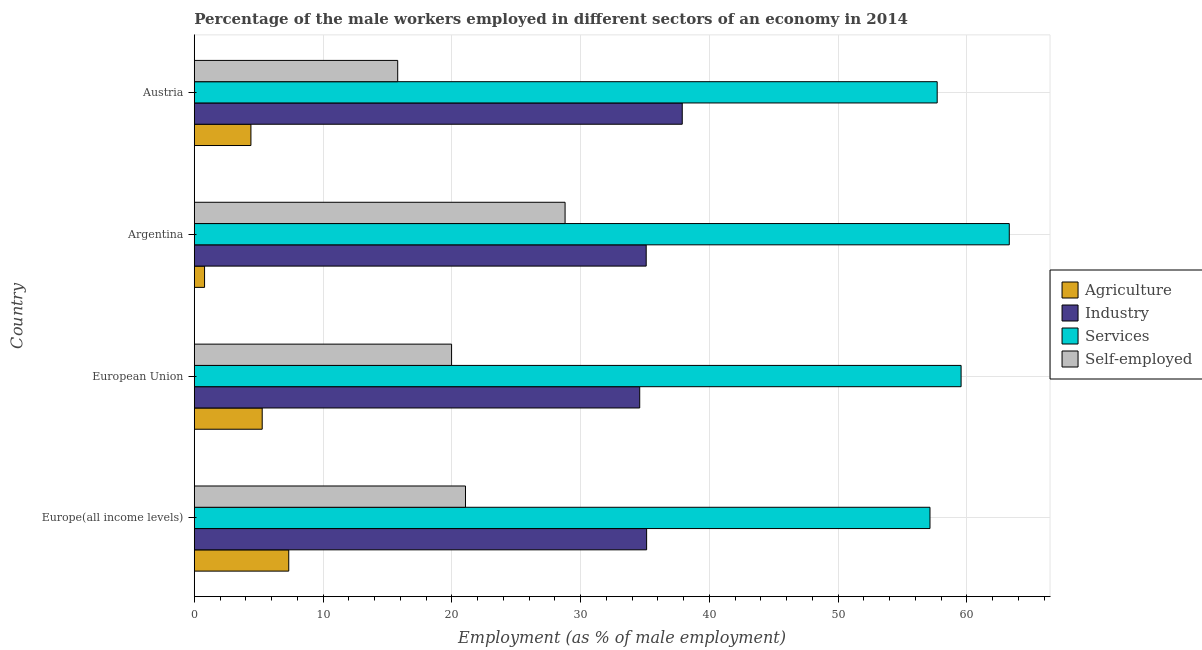How many groups of bars are there?
Give a very brief answer. 4. Are the number of bars on each tick of the Y-axis equal?
Your answer should be very brief. Yes. How many bars are there on the 1st tick from the bottom?
Give a very brief answer. 4. What is the label of the 3rd group of bars from the top?
Offer a terse response. European Union. What is the percentage of self employed male workers in Argentina?
Ensure brevity in your answer.  28.8. Across all countries, what is the maximum percentage of male workers in industry?
Your answer should be compact. 37.9. Across all countries, what is the minimum percentage of male workers in agriculture?
Your response must be concise. 0.8. In which country was the percentage of male workers in services maximum?
Provide a short and direct response. Argentina. In which country was the percentage of male workers in services minimum?
Offer a very short reply. Europe(all income levels). What is the total percentage of self employed male workers in the graph?
Provide a succinct answer. 85.65. What is the difference between the percentage of male workers in agriculture in Austria and that in European Union?
Your answer should be very brief. -0.88. What is the difference between the percentage of male workers in services in Argentina and the percentage of self employed male workers in Europe(all income levels)?
Your response must be concise. 42.24. What is the average percentage of self employed male workers per country?
Keep it short and to the point. 21.41. What is the difference between the percentage of male workers in services and percentage of male workers in industry in Argentina?
Keep it short and to the point. 28.2. In how many countries, is the percentage of male workers in services greater than 50 %?
Your answer should be very brief. 4. What is the ratio of the percentage of male workers in services in Austria to that in European Union?
Keep it short and to the point. 0.97. Is the difference between the percentage of male workers in agriculture in Austria and Europe(all income levels) greater than the difference between the percentage of self employed male workers in Austria and Europe(all income levels)?
Offer a terse response. Yes. What is the difference between the highest and the second highest percentage of male workers in services?
Offer a very short reply. 3.74. Is the sum of the percentage of male workers in agriculture in Argentina and Europe(all income levels) greater than the maximum percentage of male workers in services across all countries?
Offer a terse response. No. What does the 1st bar from the top in Austria represents?
Your answer should be very brief. Self-employed. What does the 1st bar from the bottom in Europe(all income levels) represents?
Keep it short and to the point. Agriculture. Is it the case that in every country, the sum of the percentage of male workers in agriculture and percentage of male workers in industry is greater than the percentage of male workers in services?
Keep it short and to the point. No. How many bars are there?
Provide a succinct answer. 16. Are all the bars in the graph horizontal?
Give a very brief answer. Yes. What is the difference between two consecutive major ticks on the X-axis?
Give a very brief answer. 10. Are the values on the major ticks of X-axis written in scientific E-notation?
Give a very brief answer. No. Does the graph contain any zero values?
Offer a terse response. No. How are the legend labels stacked?
Make the answer very short. Vertical. What is the title of the graph?
Keep it short and to the point. Percentage of the male workers employed in different sectors of an economy in 2014. What is the label or title of the X-axis?
Offer a very short reply. Employment (as % of male employment). What is the label or title of the Y-axis?
Your response must be concise. Country. What is the Employment (as % of male employment) in Agriculture in Europe(all income levels)?
Your answer should be very brief. 7.34. What is the Employment (as % of male employment) of Industry in Europe(all income levels)?
Offer a terse response. 35.13. What is the Employment (as % of male employment) of Services in Europe(all income levels)?
Provide a short and direct response. 57.14. What is the Employment (as % of male employment) of Self-employed in Europe(all income levels)?
Offer a very short reply. 21.06. What is the Employment (as % of male employment) of Agriculture in European Union?
Ensure brevity in your answer.  5.28. What is the Employment (as % of male employment) of Industry in European Union?
Ensure brevity in your answer.  34.6. What is the Employment (as % of male employment) in Services in European Union?
Keep it short and to the point. 59.56. What is the Employment (as % of male employment) in Self-employed in European Union?
Your answer should be very brief. 19.98. What is the Employment (as % of male employment) in Agriculture in Argentina?
Keep it short and to the point. 0.8. What is the Employment (as % of male employment) in Industry in Argentina?
Offer a very short reply. 35.1. What is the Employment (as % of male employment) in Services in Argentina?
Offer a very short reply. 63.3. What is the Employment (as % of male employment) in Self-employed in Argentina?
Your answer should be compact. 28.8. What is the Employment (as % of male employment) of Agriculture in Austria?
Keep it short and to the point. 4.4. What is the Employment (as % of male employment) in Industry in Austria?
Provide a succinct answer. 37.9. What is the Employment (as % of male employment) of Services in Austria?
Your answer should be very brief. 57.7. What is the Employment (as % of male employment) in Self-employed in Austria?
Your response must be concise. 15.8. Across all countries, what is the maximum Employment (as % of male employment) in Agriculture?
Your answer should be very brief. 7.34. Across all countries, what is the maximum Employment (as % of male employment) of Industry?
Give a very brief answer. 37.9. Across all countries, what is the maximum Employment (as % of male employment) of Services?
Your answer should be very brief. 63.3. Across all countries, what is the maximum Employment (as % of male employment) of Self-employed?
Offer a very short reply. 28.8. Across all countries, what is the minimum Employment (as % of male employment) of Agriculture?
Offer a terse response. 0.8. Across all countries, what is the minimum Employment (as % of male employment) in Industry?
Make the answer very short. 34.6. Across all countries, what is the minimum Employment (as % of male employment) in Services?
Ensure brevity in your answer.  57.14. Across all countries, what is the minimum Employment (as % of male employment) of Self-employed?
Your response must be concise. 15.8. What is the total Employment (as % of male employment) of Agriculture in the graph?
Ensure brevity in your answer.  17.82. What is the total Employment (as % of male employment) in Industry in the graph?
Make the answer very short. 142.73. What is the total Employment (as % of male employment) in Services in the graph?
Your answer should be very brief. 237.7. What is the total Employment (as % of male employment) of Self-employed in the graph?
Your answer should be compact. 85.65. What is the difference between the Employment (as % of male employment) of Agriculture in Europe(all income levels) and that in European Union?
Provide a succinct answer. 2.06. What is the difference between the Employment (as % of male employment) of Industry in Europe(all income levels) and that in European Union?
Provide a short and direct response. 0.54. What is the difference between the Employment (as % of male employment) in Services in Europe(all income levels) and that in European Union?
Ensure brevity in your answer.  -2.42. What is the difference between the Employment (as % of male employment) of Self-employed in Europe(all income levels) and that in European Union?
Give a very brief answer. 1.08. What is the difference between the Employment (as % of male employment) of Agriculture in Europe(all income levels) and that in Argentina?
Offer a very short reply. 6.54. What is the difference between the Employment (as % of male employment) of Industry in Europe(all income levels) and that in Argentina?
Give a very brief answer. 0.03. What is the difference between the Employment (as % of male employment) of Services in Europe(all income levels) and that in Argentina?
Your answer should be very brief. -6.16. What is the difference between the Employment (as % of male employment) of Self-employed in Europe(all income levels) and that in Argentina?
Ensure brevity in your answer.  -7.74. What is the difference between the Employment (as % of male employment) of Agriculture in Europe(all income levels) and that in Austria?
Keep it short and to the point. 2.94. What is the difference between the Employment (as % of male employment) in Industry in Europe(all income levels) and that in Austria?
Offer a terse response. -2.77. What is the difference between the Employment (as % of male employment) in Services in Europe(all income levels) and that in Austria?
Provide a short and direct response. -0.56. What is the difference between the Employment (as % of male employment) in Self-employed in Europe(all income levels) and that in Austria?
Ensure brevity in your answer.  5.26. What is the difference between the Employment (as % of male employment) in Agriculture in European Union and that in Argentina?
Ensure brevity in your answer.  4.48. What is the difference between the Employment (as % of male employment) of Industry in European Union and that in Argentina?
Make the answer very short. -0.5. What is the difference between the Employment (as % of male employment) of Services in European Union and that in Argentina?
Make the answer very short. -3.74. What is the difference between the Employment (as % of male employment) in Self-employed in European Union and that in Argentina?
Provide a succinct answer. -8.82. What is the difference between the Employment (as % of male employment) of Agriculture in European Union and that in Austria?
Your answer should be compact. 0.88. What is the difference between the Employment (as % of male employment) in Industry in European Union and that in Austria?
Offer a terse response. -3.3. What is the difference between the Employment (as % of male employment) in Services in European Union and that in Austria?
Offer a terse response. 1.86. What is the difference between the Employment (as % of male employment) in Self-employed in European Union and that in Austria?
Your answer should be very brief. 4.18. What is the difference between the Employment (as % of male employment) in Agriculture in Argentina and that in Austria?
Your response must be concise. -3.6. What is the difference between the Employment (as % of male employment) in Self-employed in Argentina and that in Austria?
Provide a short and direct response. 13. What is the difference between the Employment (as % of male employment) of Agriculture in Europe(all income levels) and the Employment (as % of male employment) of Industry in European Union?
Ensure brevity in your answer.  -27.26. What is the difference between the Employment (as % of male employment) of Agriculture in Europe(all income levels) and the Employment (as % of male employment) of Services in European Union?
Your answer should be compact. -52.22. What is the difference between the Employment (as % of male employment) in Agriculture in Europe(all income levels) and the Employment (as % of male employment) in Self-employed in European Union?
Provide a succinct answer. -12.65. What is the difference between the Employment (as % of male employment) in Industry in Europe(all income levels) and the Employment (as % of male employment) in Services in European Union?
Offer a very short reply. -24.42. What is the difference between the Employment (as % of male employment) in Industry in Europe(all income levels) and the Employment (as % of male employment) in Self-employed in European Union?
Your answer should be very brief. 15.15. What is the difference between the Employment (as % of male employment) in Services in Europe(all income levels) and the Employment (as % of male employment) in Self-employed in European Union?
Provide a succinct answer. 37.16. What is the difference between the Employment (as % of male employment) in Agriculture in Europe(all income levels) and the Employment (as % of male employment) in Industry in Argentina?
Offer a terse response. -27.76. What is the difference between the Employment (as % of male employment) of Agriculture in Europe(all income levels) and the Employment (as % of male employment) of Services in Argentina?
Keep it short and to the point. -55.96. What is the difference between the Employment (as % of male employment) in Agriculture in Europe(all income levels) and the Employment (as % of male employment) in Self-employed in Argentina?
Provide a short and direct response. -21.46. What is the difference between the Employment (as % of male employment) in Industry in Europe(all income levels) and the Employment (as % of male employment) in Services in Argentina?
Your answer should be compact. -28.17. What is the difference between the Employment (as % of male employment) in Industry in Europe(all income levels) and the Employment (as % of male employment) in Self-employed in Argentina?
Give a very brief answer. 6.33. What is the difference between the Employment (as % of male employment) in Services in Europe(all income levels) and the Employment (as % of male employment) in Self-employed in Argentina?
Your answer should be very brief. 28.34. What is the difference between the Employment (as % of male employment) in Agriculture in Europe(all income levels) and the Employment (as % of male employment) in Industry in Austria?
Your response must be concise. -30.56. What is the difference between the Employment (as % of male employment) in Agriculture in Europe(all income levels) and the Employment (as % of male employment) in Services in Austria?
Give a very brief answer. -50.36. What is the difference between the Employment (as % of male employment) of Agriculture in Europe(all income levels) and the Employment (as % of male employment) of Self-employed in Austria?
Ensure brevity in your answer.  -8.46. What is the difference between the Employment (as % of male employment) in Industry in Europe(all income levels) and the Employment (as % of male employment) in Services in Austria?
Provide a succinct answer. -22.57. What is the difference between the Employment (as % of male employment) in Industry in Europe(all income levels) and the Employment (as % of male employment) in Self-employed in Austria?
Your answer should be very brief. 19.33. What is the difference between the Employment (as % of male employment) of Services in Europe(all income levels) and the Employment (as % of male employment) of Self-employed in Austria?
Give a very brief answer. 41.34. What is the difference between the Employment (as % of male employment) of Agriculture in European Union and the Employment (as % of male employment) of Industry in Argentina?
Keep it short and to the point. -29.82. What is the difference between the Employment (as % of male employment) in Agriculture in European Union and the Employment (as % of male employment) in Services in Argentina?
Provide a short and direct response. -58.02. What is the difference between the Employment (as % of male employment) of Agriculture in European Union and the Employment (as % of male employment) of Self-employed in Argentina?
Your response must be concise. -23.52. What is the difference between the Employment (as % of male employment) in Industry in European Union and the Employment (as % of male employment) in Services in Argentina?
Ensure brevity in your answer.  -28.7. What is the difference between the Employment (as % of male employment) in Industry in European Union and the Employment (as % of male employment) in Self-employed in Argentina?
Your answer should be compact. 5.8. What is the difference between the Employment (as % of male employment) in Services in European Union and the Employment (as % of male employment) in Self-employed in Argentina?
Ensure brevity in your answer.  30.76. What is the difference between the Employment (as % of male employment) of Agriculture in European Union and the Employment (as % of male employment) of Industry in Austria?
Keep it short and to the point. -32.62. What is the difference between the Employment (as % of male employment) in Agriculture in European Union and the Employment (as % of male employment) in Services in Austria?
Offer a terse response. -52.42. What is the difference between the Employment (as % of male employment) in Agriculture in European Union and the Employment (as % of male employment) in Self-employed in Austria?
Keep it short and to the point. -10.52. What is the difference between the Employment (as % of male employment) in Industry in European Union and the Employment (as % of male employment) in Services in Austria?
Keep it short and to the point. -23.1. What is the difference between the Employment (as % of male employment) in Industry in European Union and the Employment (as % of male employment) in Self-employed in Austria?
Make the answer very short. 18.8. What is the difference between the Employment (as % of male employment) of Services in European Union and the Employment (as % of male employment) of Self-employed in Austria?
Offer a terse response. 43.76. What is the difference between the Employment (as % of male employment) in Agriculture in Argentina and the Employment (as % of male employment) in Industry in Austria?
Offer a terse response. -37.1. What is the difference between the Employment (as % of male employment) in Agriculture in Argentina and the Employment (as % of male employment) in Services in Austria?
Offer a very short reply. -56.9. What is the difference between the Employment (as % of male employment) in Industry in Argentina and the Employment (as % of male employment) in Services in Austria?
Provide a succinct answer. -22.6. What is the difference between the Employment (as % of male employment) of Industry in Argentina and the Employment (as % of male employment) of Self-employed in Austria?
Offer a very short reply. 19.3. What is the difference between the Employment (as % of male employment) of Services in Argentina and the Employment (as % of male employment) of Self-employed in Austria?
Ensure brevity in your answer.  47.5. What is the average Employment (as % of male employment) of Agriculture per country?
Offer a very short reply. 4.45. What is the average Employment (as % of male employment) of Industry per country?
Provide a short and direct response. 35.68. What is the average Employment (as % of male employment) in Services per country?
Offer a terse response. 59.42. What is the average Employment (as % of male employment) in Self-employed per country?
Offer a terse response. 21.41. What is the difference between the Employment (as % of male employment) in Agriculture and Employment (as % of male employment) in Industry in Europe(all income levels)?
Offer a very short reply. -27.8. What is the difference between the Employment (as % of male employment) of Agriculture and Employment (as % of male employment) of Services in Europe(all income levels)?
Your response must be concise. -49.8. What is the difference between the Employment (as % of male employment) of Agriculture and Employment (as % of male employment) of Self-employed in Europe(all income levels)?
Your response must be concise. -13.73. What is the difference between the Employment (as % of male employment) in Industry and Employment (as % of male employment) in Services in Europe(all income levels)?
Offer a very short reply. -22.01. What is the difference between the Employment (as % of male employment) of Industry and Employment (as % of male employment) of Self-employed in Europe(all income levels)?
Offer a very short reply. 14.07. What is the difference between the Employment (as % of male employment) of Services and Employment (as % of male employment) of Self-employed in Europe(all income levels)?
Offer a very short reply. 36.08. What is the difference between the Employment (as % of male employment) of Agriculture and Employment (as % of male employment) of Industry in European Union?
Provide a succinct answer. -29.32. What is the difference between the Employment (as % of male employment) in Agriculture and Employment (as % of male employment) in Services in European Union?
Ensure brevity in your answer.  -54.28. What is the difference between the Employment (as % of male employment) of Agriculture and Employment (as % of male employment) of Self-employed in European Union?
Provide a short and direct response. -14.71. What is the difference between the Employment (as % of male employment) of Industry and Employment (as % of male employment) of Services in European Union?
Keep it short and to the point. -24.96. What is the difference between the Employment (as % of male employment) in Industry and Employment (as % of male employment) in Self-employed in European Union?
Your answer should be very brief. 14.61. What is the difference between the Employment (as % of male employment) of Services and Employment (as % of male employment) of Self-employed in European Union?
Your answer should be compact. 39.57. What is the difference between the Employment (as % of male employment) of Agriculture and Employment (as % of male employment) of Industry in Argentina?
Your answer should be compact. -34.3. What is the difference between the Employment (as % of male employment) in Agriculture and Employment (as % of male employment) in Services in Argentina?
Offer a terse response. -62.5. What is the difference between the Employment (as % of male employment) of Industry and Employment (as % of male employment) of Services in Argentina?
Your answer should be very brief. -28.2. What is the difference between the Employment (as % of male employment) in Services and Employment (as % of male employment) in Self-employed in Argentina?
Ensure brevity in your answer.  34.5. What is the difference between the Employment (as % of male employment) of Agriculture and Employment (as % of male employment) of Industry in Austria?
Keep it short and to the point. -33.5. What is the difference between the Employment (as % of male employment) of Agriculture and Employment (as % of male employment) of Services in Austria?
Ensure brevity in your answer.  -53.3. What is the difference between the Employment (as % of male employment) of Industry and Employment (as % of male employment) of Services in Austria?
Keep it short and to the point. -19.8. What is the difference between the Employment (as % of male employment) in Industry and Employment (as % of male employment) in Self-employed in Austria?
Ensure brevity in your answer.  22.1. What is the difference between the Employment (as % of male employment) in Services and Employment (as % of male employment) in Self-employed in Austria?
Keep it short and to the point. 41.9. What is the ratio of the Employment (as % of male employment) in Agriculture in Europe(all income levels) to that in European Union?
Provide a short and direct response. 1.39. What is the ratio of the Employment (as % of male employment) in Industry in Europe(all income levels) to that in European Union?
Give a very brief answer. 1.02. What is the ratio of the Employment (as % of male employment) of Services in Europe(all income levels) to that in European Union?
Offer a very short reply. 0.96. What is the ratio of the Employment (as % of male employment) in Self-employed in Europe(all income levels) to that in European Union?
Offer a very short reply. 1.05. What is the ratio of the Employment (as % of male employment) in Agriculture in Europe(all income levels) to that in Argentina?
Your answer should be very brief. 9.17. What is the ratio of the Employment (as % of male employment) in Industry in Europe(all income levels) to that in Argentina?
Your response must be concise. 1. What is the ratio of the Employment (as % of male employment) of Services in Europe(all income levels) to that in Argentina?
Your answer should be compact. 0.9. What is the ratio of the Employment (as % of male employment) of Self-employed in Europe(all income levels) to that in Argentina?
Your answer should be very brief. 0.73. What is the ratio of the Employment (as % of male employment) in Agriculture in Europe(all income levels) to that in Austria?
Give a very brief answer. 1.67. What is the ratio of the Employment (as % of male employment) of Industry in Europe(all income levels) to that in Austria?
Offer a very short reply. 0.93. What is the ratio of the Employment (as % of male employment) in Services in Europe(all income levels) to that in Austria?
Give a very brief answer. 0.99. What is the ratio of the Employment (as % of male employment) of Self-employed in Europe(all income levels) to that in Austria?
Your response must be concise. 1.33. What is the ratio of the Employment (as % of male employment) of Agriculture in European Union to that in Argentina?
Ensure brevity in your answer.  6.6. What is the ratio of the Employment (as % of male employment) in Industry in European Union to that in Argentina?
Offer a terse response. 0.99. What is the ratio of the Employment (as % of male employment) of Services in European Union to that in Argentina?
Your answer should be very brief. 0.94. What is the ratio of the Employment (as % of male employment) in Self-employed in European Union to that in Argentina?
Your answer should be compact. 0.69. What is the ratio of the Employment (as % of male employment) in Agriculture in European Union to that in Austria?
Make the answer very short. 1.2. What is the ratio of the Employment (as % of male employment) of Industry in European Union to that in Austria?
Provide a succinct answer. 0.91. What is the ratio of the Employment (as % of male employment) of Services in European Union to that in Austria?
Make the answer very short. 1.03. What is the ratio of the Employment (as % of male employment) of Self-employed in European Union to that in Austria?
Make the answer very short. 1.26. What is the ratio of the Employment (as % of male employment) in Agriculture in Argentina to that in Austria?
Provide a short and direct response. 0.18. What is the ratio of the Employment (as % of male employment) in Industry in Argentina to that in Austria?
Make the answer very short. 0.93. What is the ratio of the Employment (as % of male employment) in Services in Argentina to that in Austria?
Your response must be concise. 1.1. What is the ratio of the Employment (as % of male employment) in Self-employed in Argentina to that in Austria?
Keep it short and to the point. 1.82. What is the difference between the highest and the second highest Employment (as % of male employment) in Agriculture?
Offer a terse response. 2.06. What is the difference between the highest and the second highest Employment (as % of male employment) in Industry?
Your answer should be very brief. 2.77. What is the difference between the highest and the second highest Employment (as % of male employment) in Services?
Give a very brief answer. 3.74. What is the difference between the highest and the second highest Employment (as % of male employment) of Self-employed?
Provide a short and direct response. 7.74. What is the difference between the highest and the lowest Employment (as % of male employment) of Agriculture?
Your answer should be compact. 6.54. What is the difference between the highest and the lowest Employment (as % of male employment) in Industry?
Offer a terse response. 3.3. What is the difference between the highest and the lowest Employment (as % of male employment) of Services?
Keep it short and to the point. 6.16. 